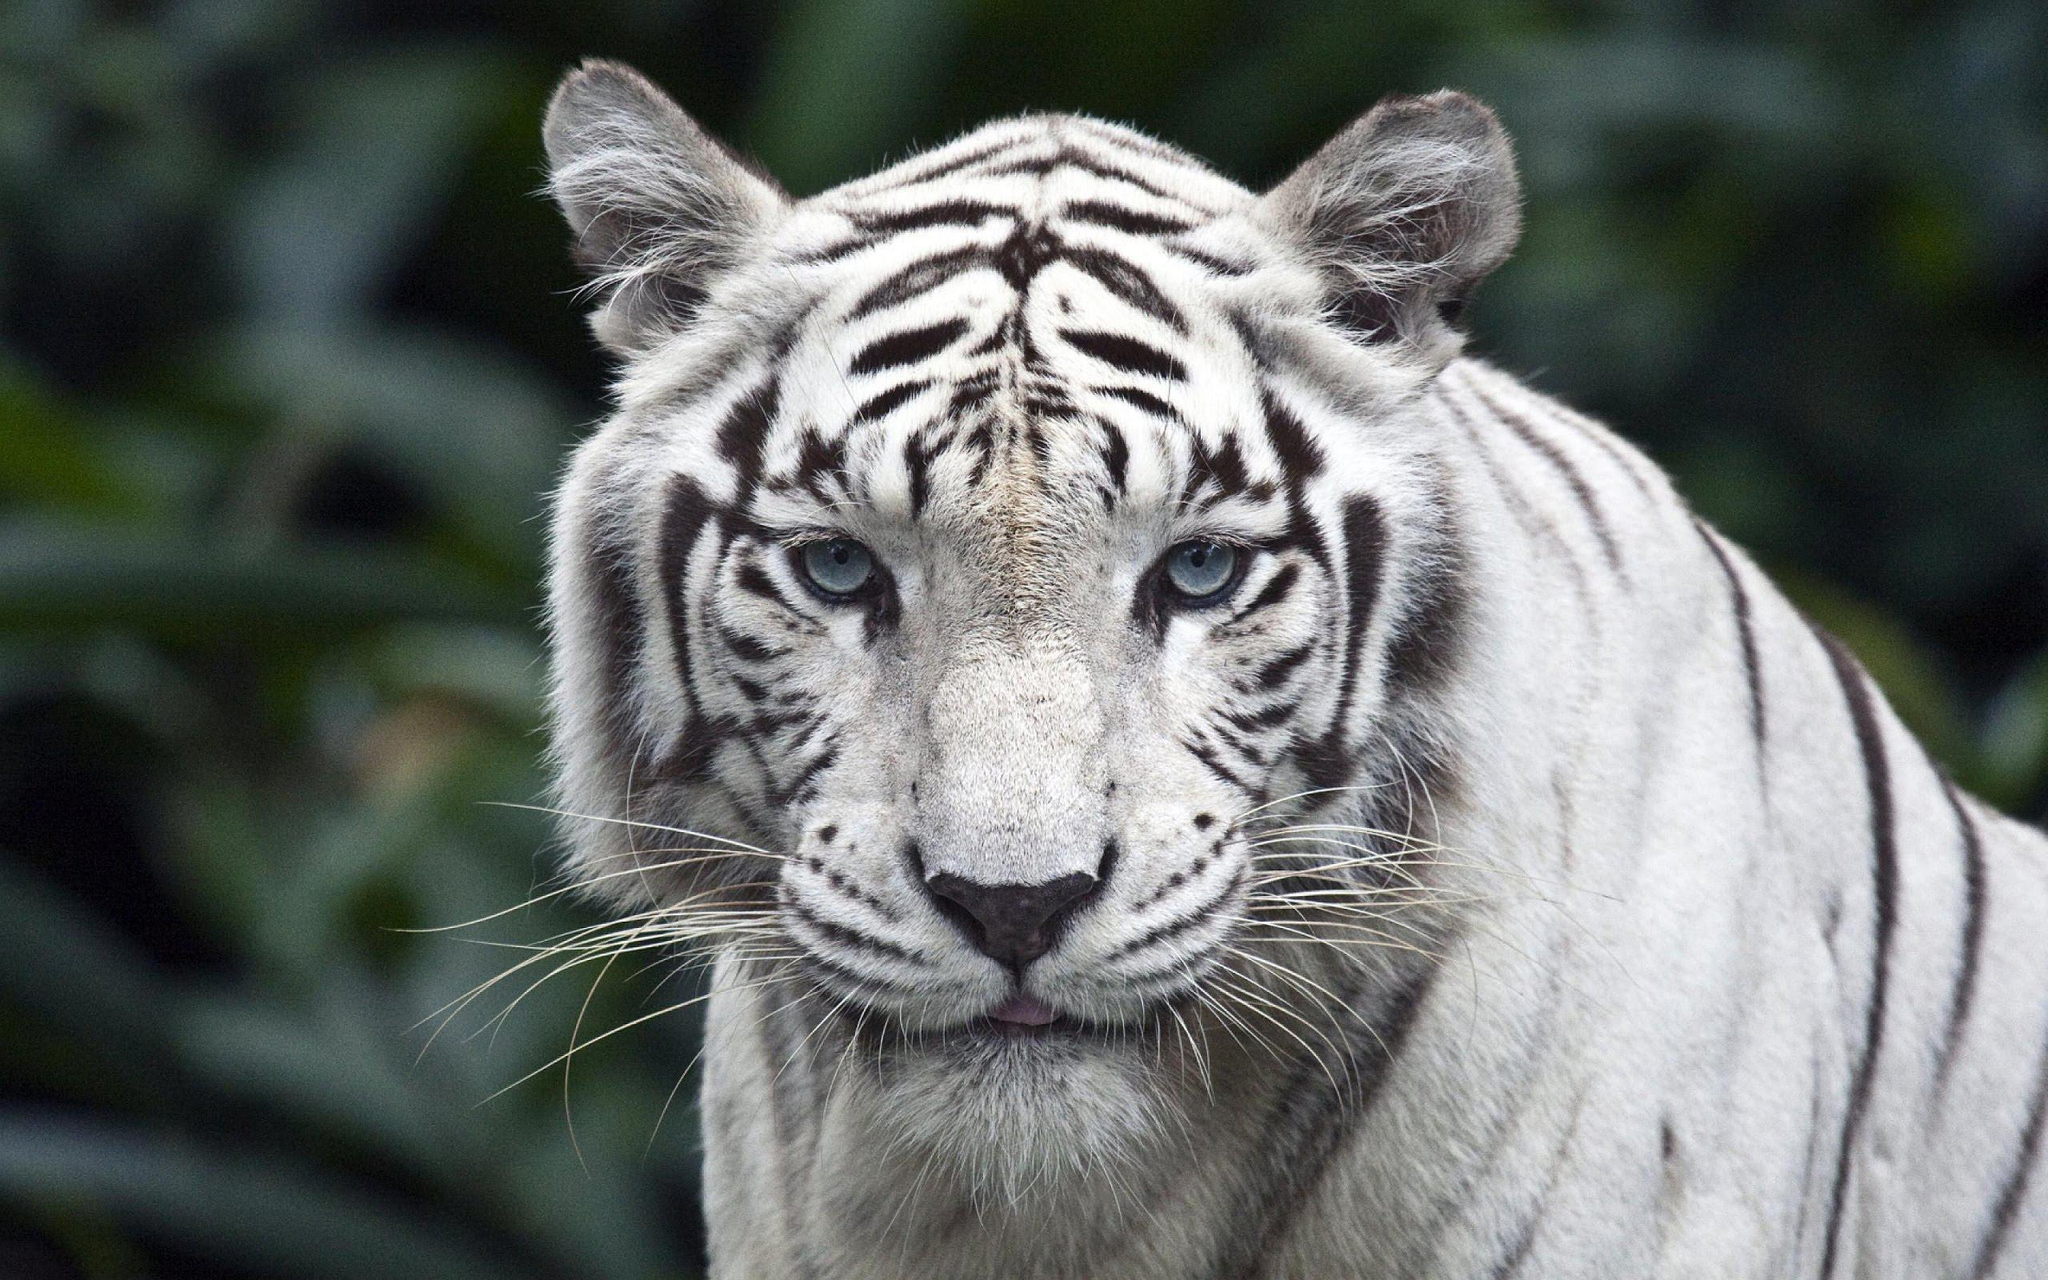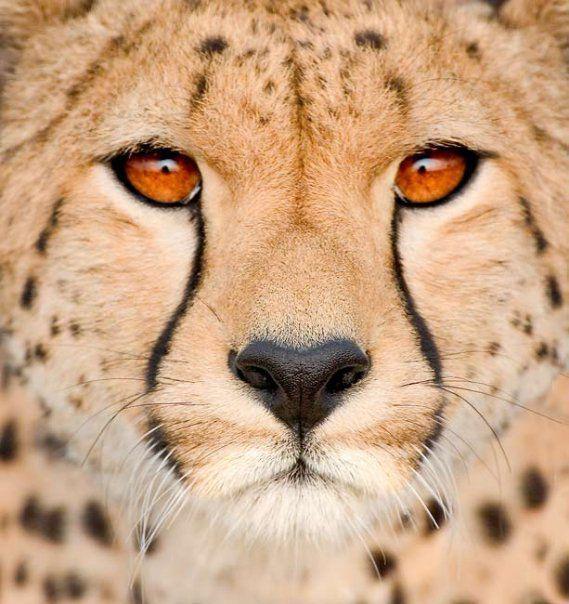The first image is the image on the left, the second image is the image on the right. Given the left and right images, does the statement "The left image contains exactly three cheetahs." hold true? Answer yes or no. No. The first image is the image on the left, the second image is the image on the right. Given the left and right images, does the statement "At least three cubs and one adult leopard are visible." hold true? Answer yes or no. No. 